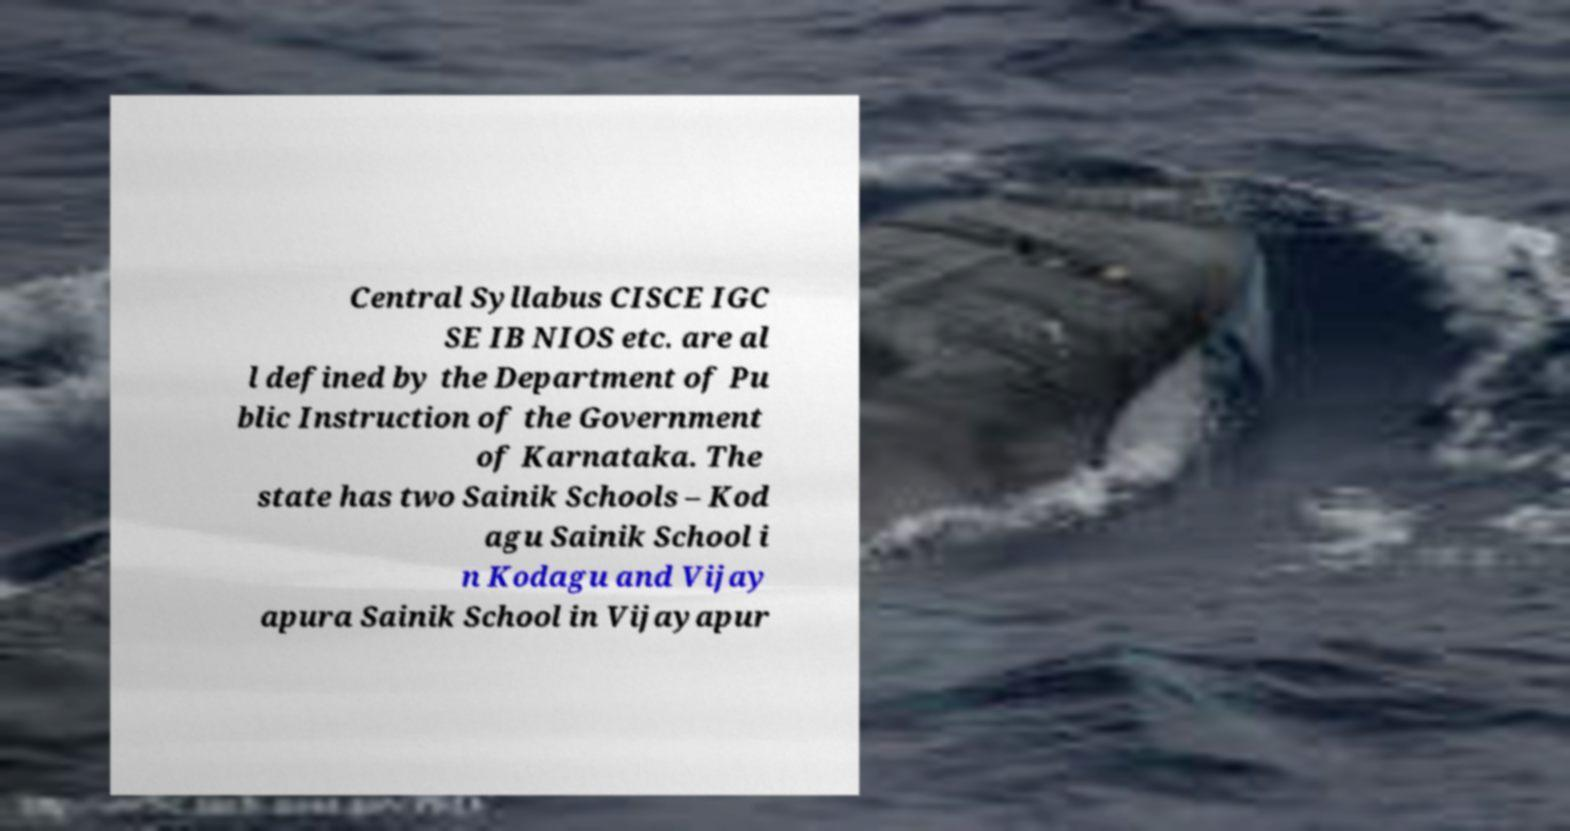What messages or text are displayed in this image? I need them in a readable, typed format. Central Syllabus CISCE IGC SE IB NIOS etc. are al l defined by the Department of Pu blic Instruction of the Government of Karnataka. The state has two Sainik Schools – Kod agu Sainik School i n Kodagu and Vijay apura Sainik School in Vijayapur 